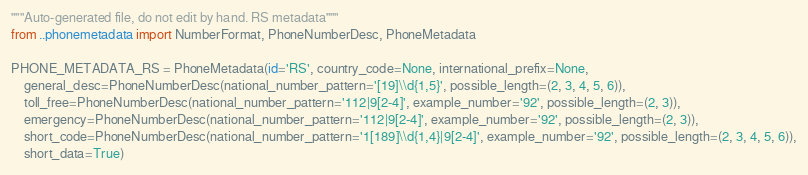<code> <loc_0><loc_0><loc_500><loc_500><_Python_>"""Auto-generated file, do not edit by hand. RS metadata"""
from ..phonemetadata import NumberFormat, PhoneNumberDesc, PhoneMetadata

PHONE_METADATA_RS = PhoneMetadata(id='RS', country_code=None, international_prefix=None,
    general_desc=PhoneNumberDesc(national_number_pattern='[19]\\d{1,5}', possible_length=(2, 3, 4, 5, 6)),
    toll_free=PhoneNumberDesc(national_number_pattern='112|9[2-4]', example_number='92', possible_length=(2, 3)),
    emergency=PhoneNumberDesc(national_number_pattern='112|9[2-4]', example_number='92', possible_length=(2, 3)),
    short_code=PhoneNumberDesc(national_number_pattern='1[189]\\d{1,4}|9[2-4]', example_number='92', possible_length=(2, 3, 4, 5, 6)),
    short_data=True)
</code> 